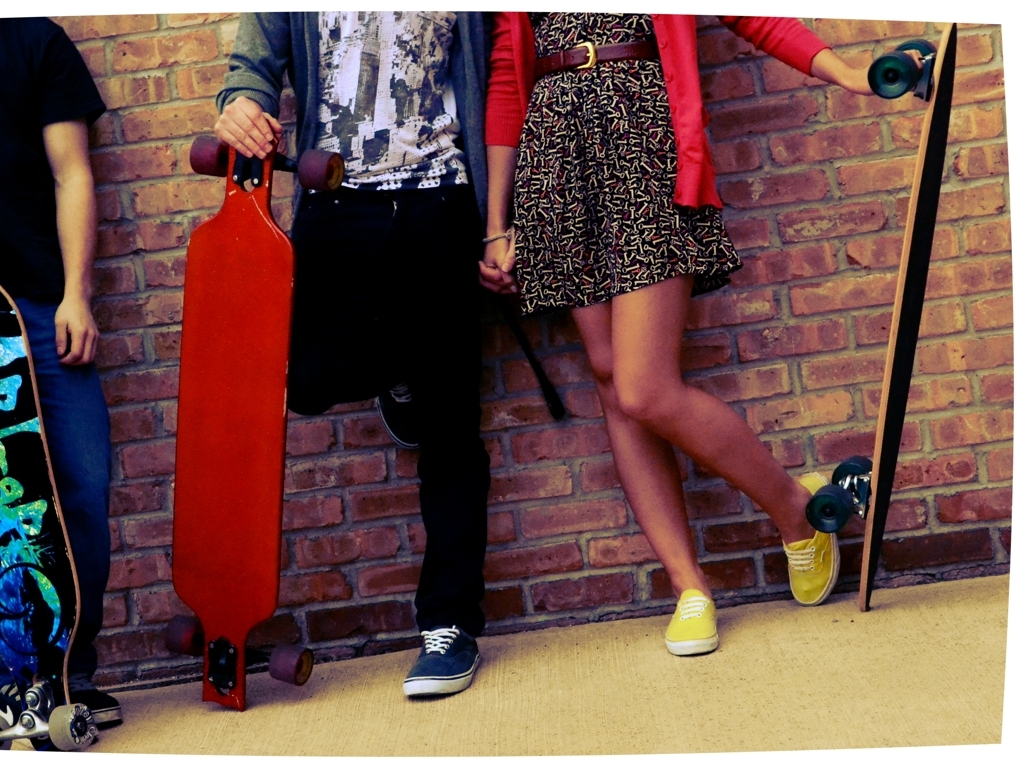What is the quality of this image?
A. Poor
B. Excellent
C. Relatively good
D. Mediocre The quality of the image is 'C. Relatively good', which means that while the image is generally clear with the subjects and their actions being discernible and the colors vivid, there are certain aspects like sharpness, contrast, or composition that could be improved to reach an 'excellent' standard. 